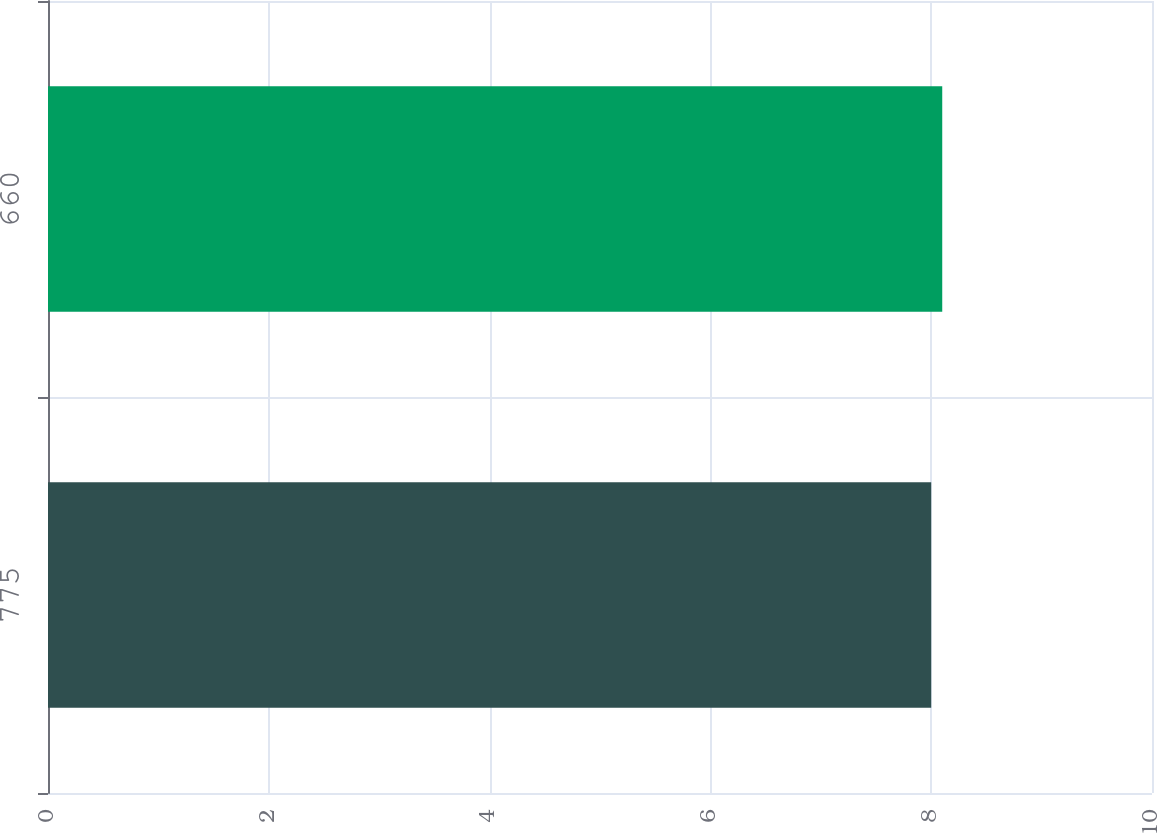<chart> <loc_0><loc_0><loc_500><loc_500><bar_chart><fcel>775<fcel>660<nl><fcel>8<fcel>8.1<nl></chart> 